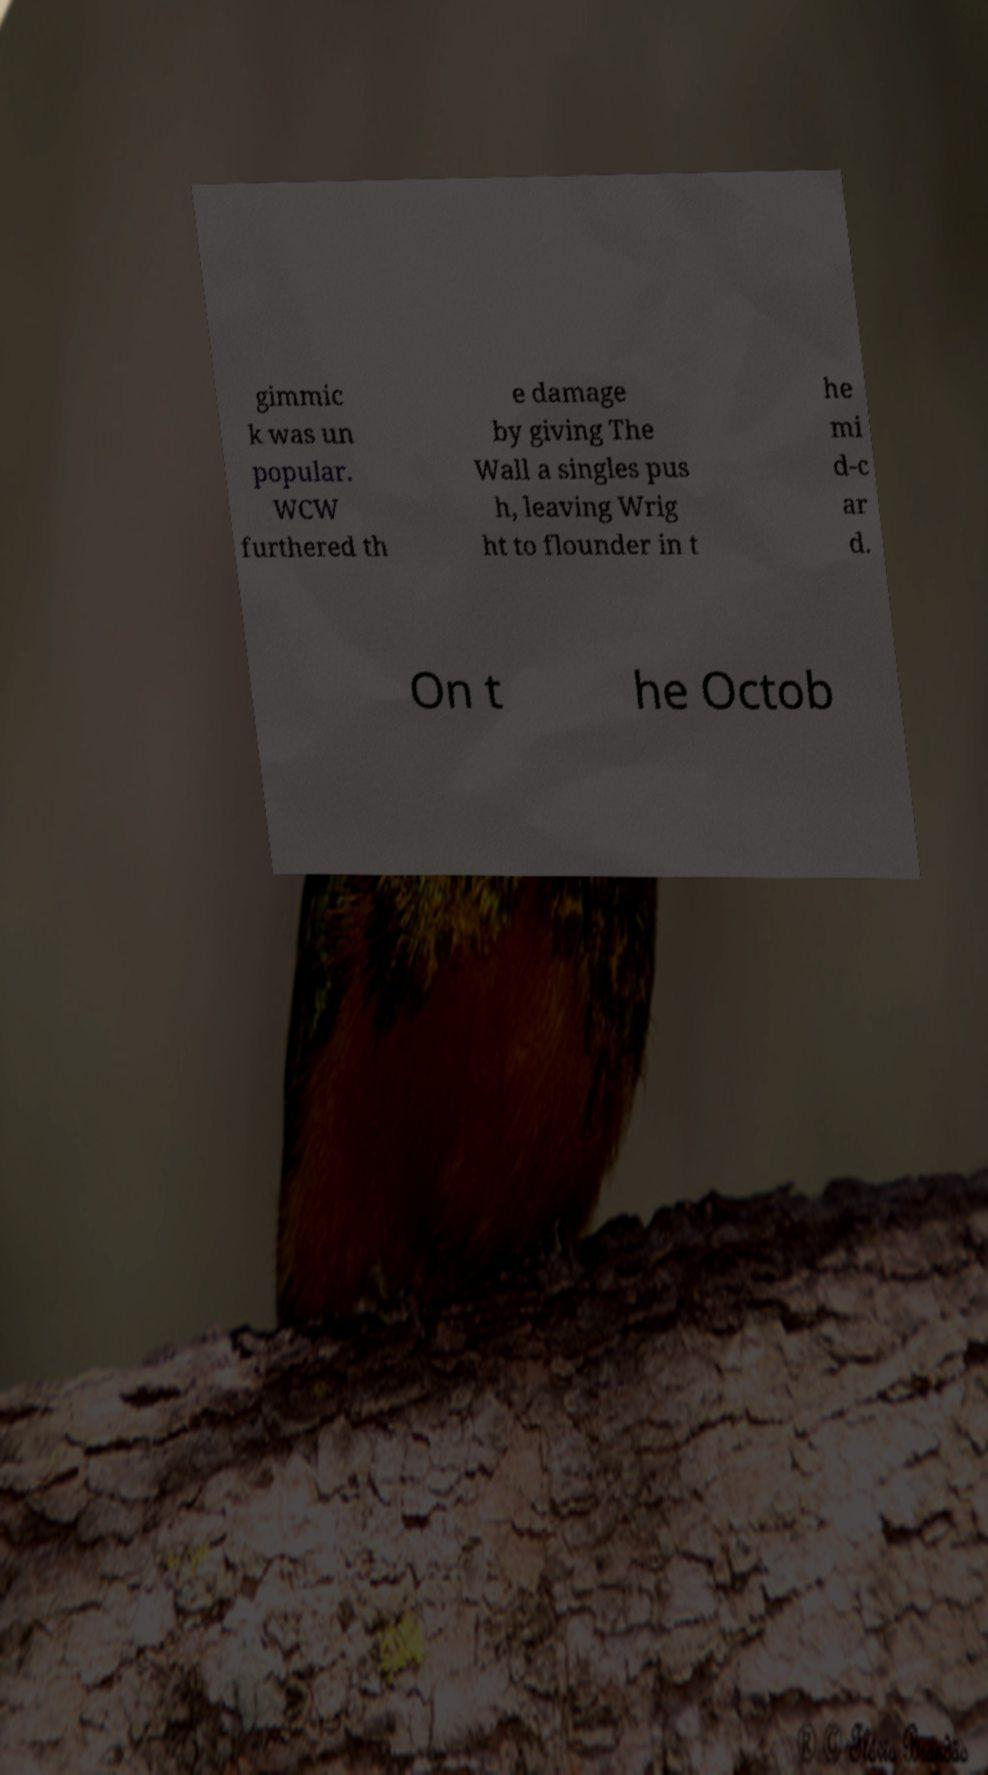I need the written content from this picture converted into text. Can you do that? gimmic k was un popular. WCW furthered th e damage by giving The Wall a singles pus h, leaving Wrig ht to flounder in t he mi d-c ar d. On t he Octob 